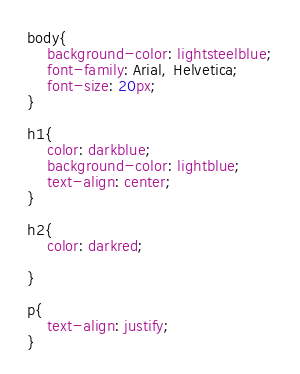Convert code to text. <code><loc_0><loc_0><loc_500><loc_500><_CSS_>body{
    background-color: lightsteelblue;
    font-family: Arial, Helvetica;
    font-size: 20px;
}

h1{
    color: darkblue;
    background-color: lightblue;
    text-align: center;
}

h2{
    color: darkred;

}

p{
    text-align: justify;
}</code> 